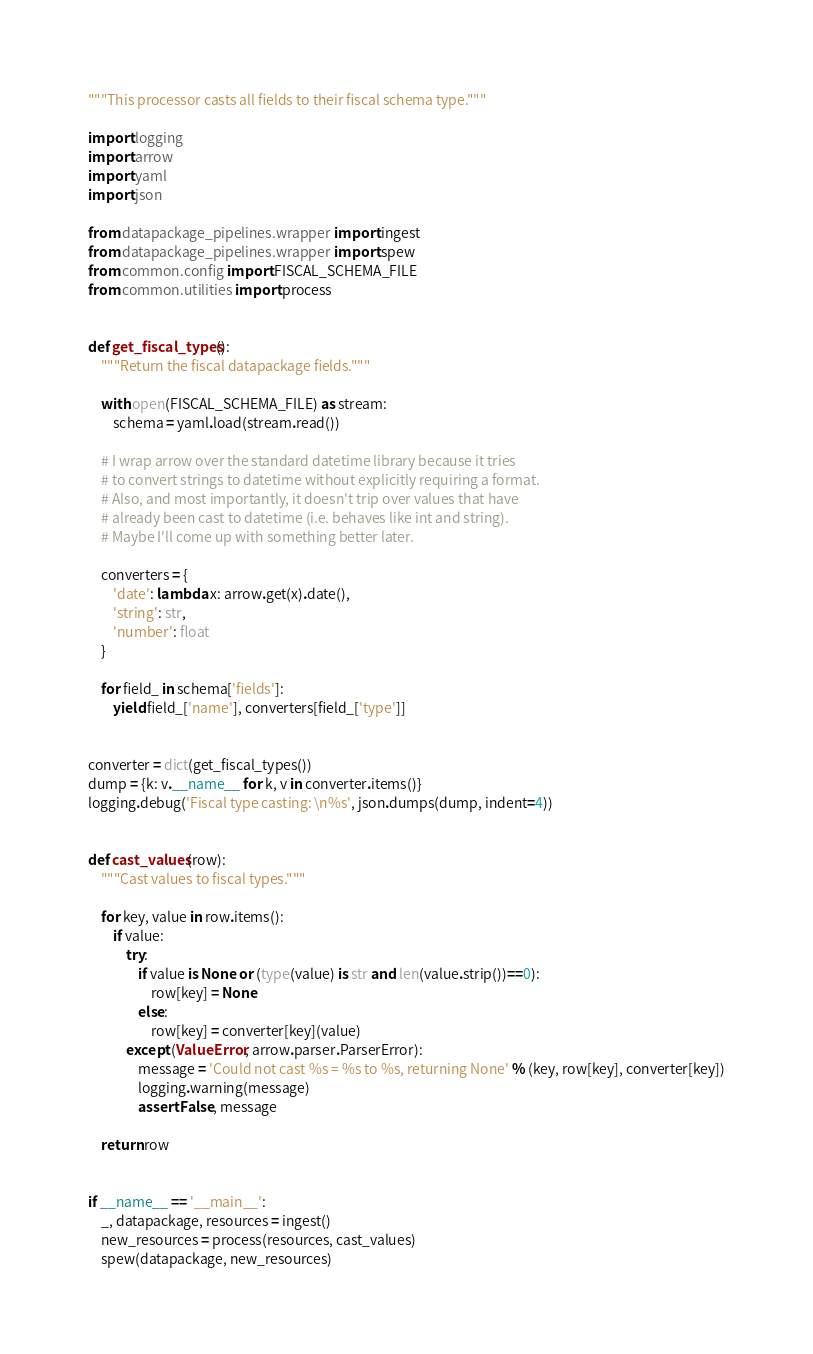Convert code to text. <code><loc_0><loc_0><loc_500><loc_500><_Python_>"""This processor casts all fields to their fiscal schema type."""

import logging
import arrow
import yaml
import json

from datapackage_pipelines.wrapper import ingest
from datapackage_pipelines.wrapper import spew
from common.config import FISCAL_SCHEMA_FILE
from common.utilities import process


def get_fiscal_types():
    """Return the fiscal datapackage fields."""

    with open(FISCAL_SCHEMA_FILE) as stream:
        schema = yaml.load(stream.read())

    # I wrap arrow over the standard datetime library because it tries
    # to convert strings to datetime without explicitly requiring a format.
    # Also, and most importantly, it doesn't trip over values that have
    # already been cast to datetime (i.e. behaves like int and string).
    # Maybe I'll come up with something better later.

    converters = {
        'date': lambda x: arrow.get(x).date(),
        'string': str,
        'number': float
    }

    for field_ in schema['fields']:
        yield field_['name'], converters[field_['type']]


converter = dict(get_fiscal_types())
dump = {k: v.__name__ for k, v in converter.items()}
logging.debug('Fiscal type casting: \n%s', json.dumps(dump, indent=4))


def cast_values(row):
    """Cast values to fiscal types."""

    for key, value in row.items():
        if value:
            try:
                if value is None or (type(value) is str and len(value.strip())==0):
                    row[key] = None
                else:
                    row[key] = converter[key](value)
            except (ValueError, arrow.parser.ParserError):
                message = 'Could not cast %s = %s to %s, returning None' % (key, row[key], converter[key])
                logging.warning(message)
                assert False, message

    return row


if __name__ == '__main__':
    _, datapackage, resources = ingest()
    new_resources = process(resources, cast_values)
    spew(datapackage, new_resources)
</code> 